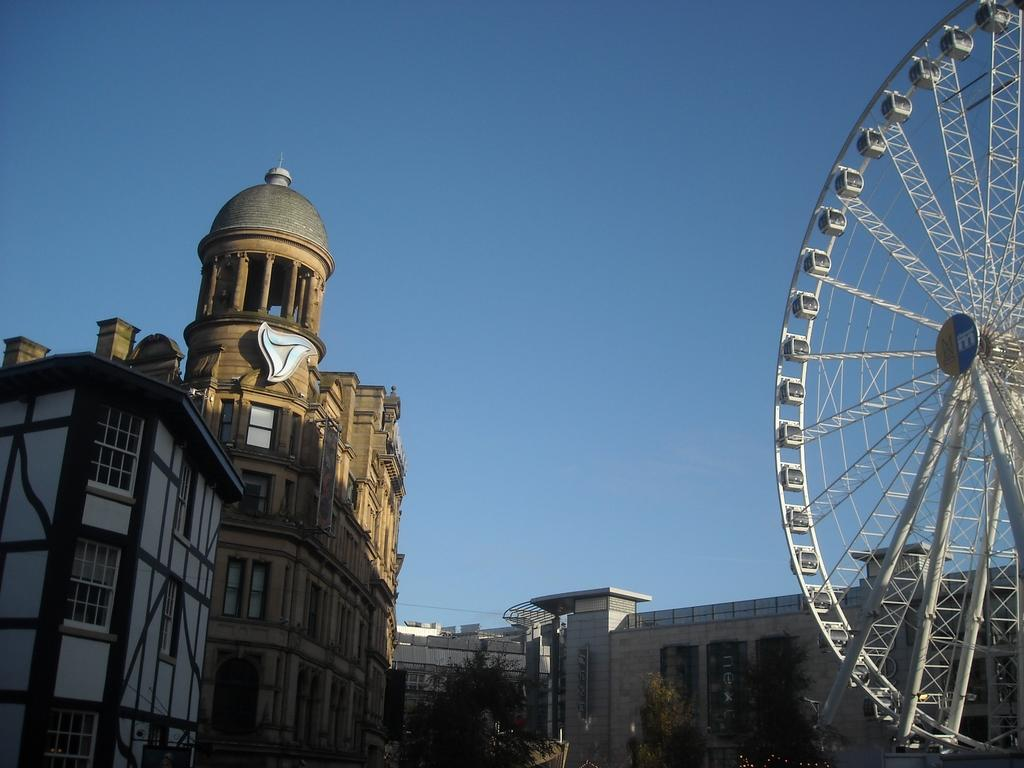What type of structures can be seen in the image? There are buildings in the image. What other natural elements are present in the image? There are trees in the image. Can you describe the object that looks like a wheel in the image? Yes, it is a joint wheel. What is visible in the background of the image? The sky is visible in the background of the image. How many yards of grass are visible in the image? There is no yard or grass present in the image; it features buildings, trees, and a joint wheel. What type of growth can be seen on the trees in the image? There is no visible growth on the trees in the image, as it only shows the trees' trunks and branches. --- Facts: 1. There is a person in the image. 2. The person is wearing a hat. 3. The person is holding a book. 4. There is a table in the image. 5. The table has a lamp on it. Absurd Topics: parrot, ocean, mountain Conversation: Who is present in the image? There is a person in the image. What is the person wearing in the image? The person is wearing a hat in the image. What is the person holding in the image? The person is holding a book in the image. What object can be seen on the table in the image? There is a lamp on the table in the image. Reasoning: Let's think step by step in order to produce the conversation. We start by identifying the main subject in the image, which is the person. Then, we describe the person's attire, specifically mentioning the hat. Next, we observe the action of the person, noting that they are holding a book. Finally, we describe the object on the table, which is a lamp. Absurd Question/Answer: Can you see any parrots in the image? No, there are no parrots present in the image. 